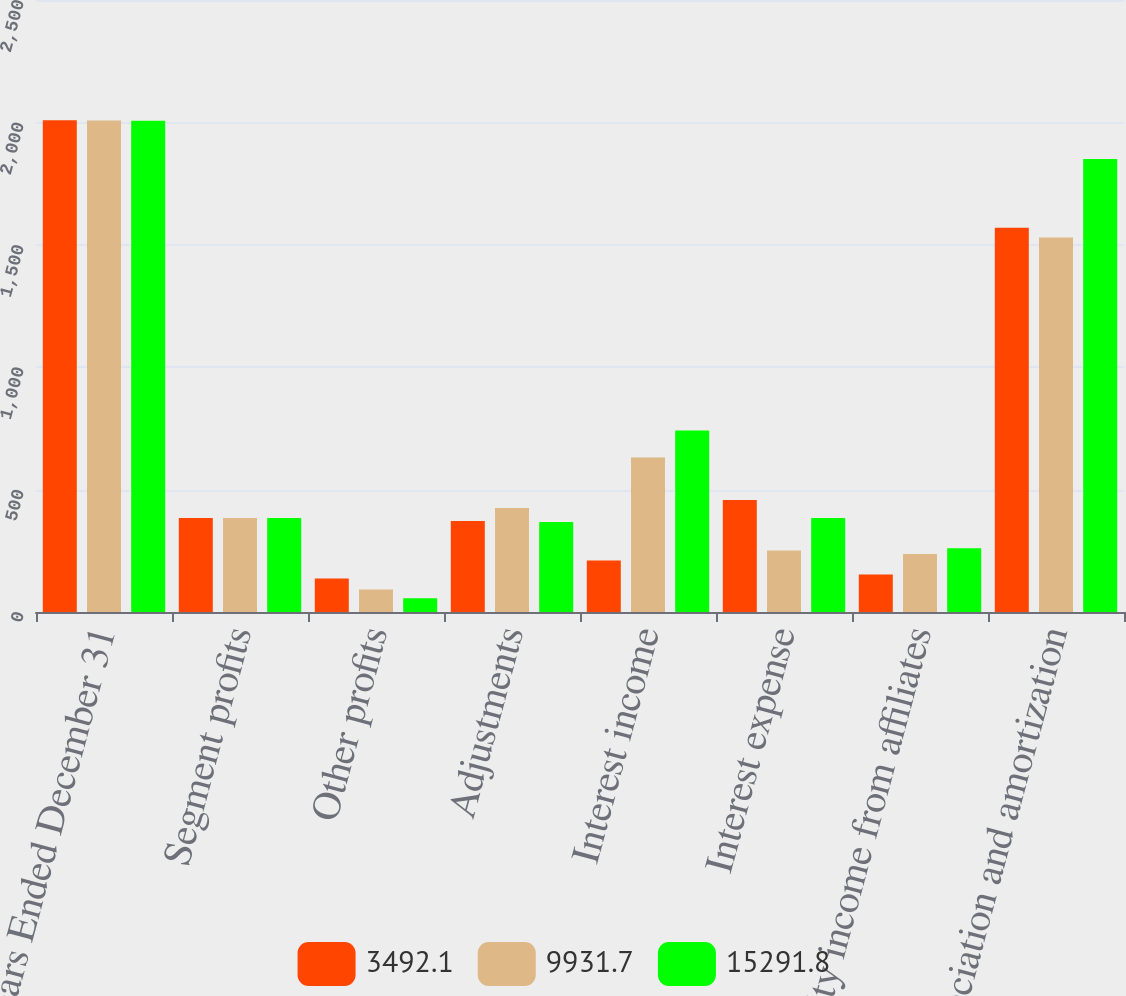Convert chart. <chart><loc_0><loc_0><loc_500><loc_500><stacked_bar_chart><ecel><fcel>Years Ended December 31<fcel>Segment profits<fcel>Other profits<fcel>Adjustments<fcel>Interest income<fcel>Interest expense<fcel>Equity income from affiliates<fcel>Depreciation and amortization<nl><fcel>3492.1<fcel>2009<fcel>384.3<fcel>136.7<fcel>372<fcel>210.2<fcel>458<fcel>153.2<fcel>1569.6<nl><fcel>9931.7<fcel>2008<fcel>384.3<fcel>92.3<fcel>424.7<fcel>631.4<fcel>251.3<fcel>236.5<fcel>1529.8<nl><fcel>15291.8<fcel>2007<fcel>384.3<fcel>56.2<fcel>367.7<fcel>741.1<fcel>384.3<fcel>260.6<fcel>1851<nl></chart> 